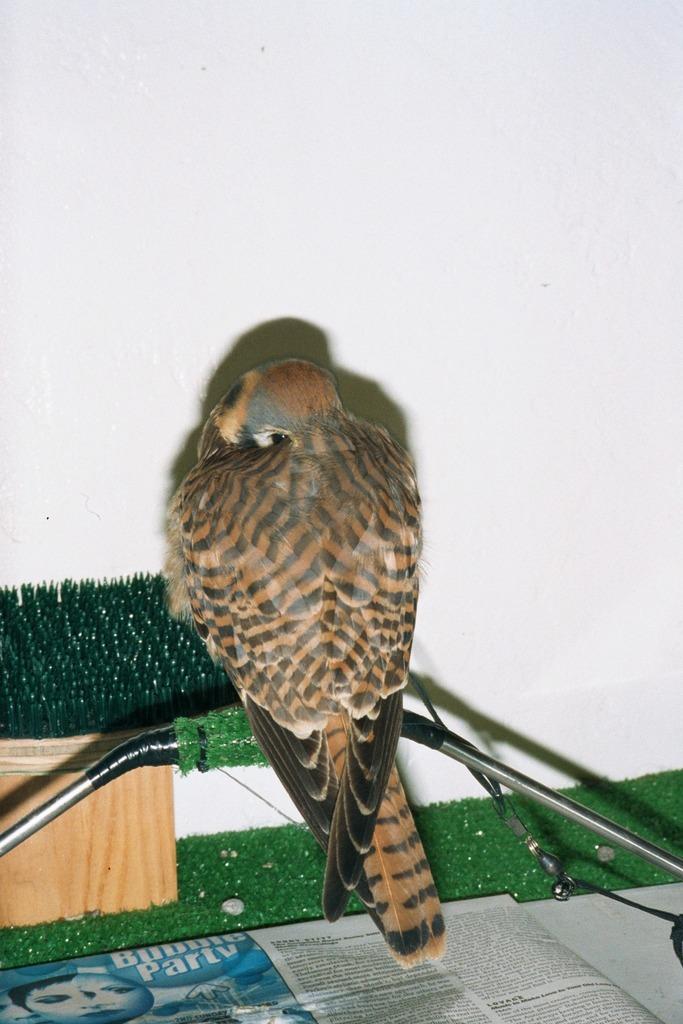Could you give a brief overview of what you see in this image? This picture is clicked inside the room. The bird in the middle of the picture is on the thin iron rod. Behind that, we see a wall in white color. At the bottom of the picture, we see a newspaper and an artificial grass. 